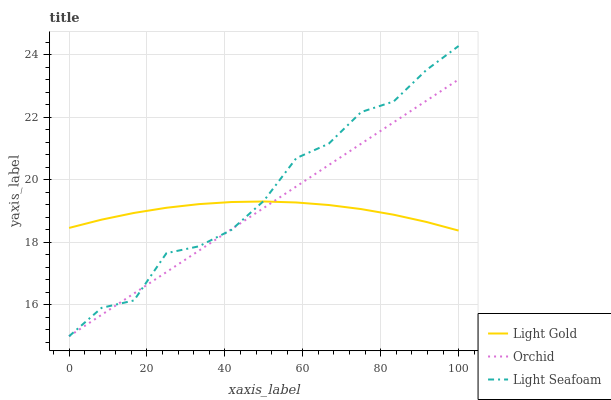Does Light Gold have the minimum area under the curve?
Answer yes or no. Yes. Does Light Seafoam have the maximum area under the curve?
Answer yes or no. Yes. Does Orchid have the minimum area under the curve?
Answer yes or no. No. Does Orchid have the maximum area under the curve?
Answer yes or no. No. Is Orchid the smoothest?
Answer yes or no. Yes. Is Light Seafoam the roughest?
Answer yes or no. Yes. Is Light Gold the smoothest?
Answer yes or no. No. Is Light Gold the roughest?
Answer yes or no. No. Does Light Gold have the lowest value?
Answer yes or no. No. Does Orchid have the highest value?
Answer yes or no. No. 